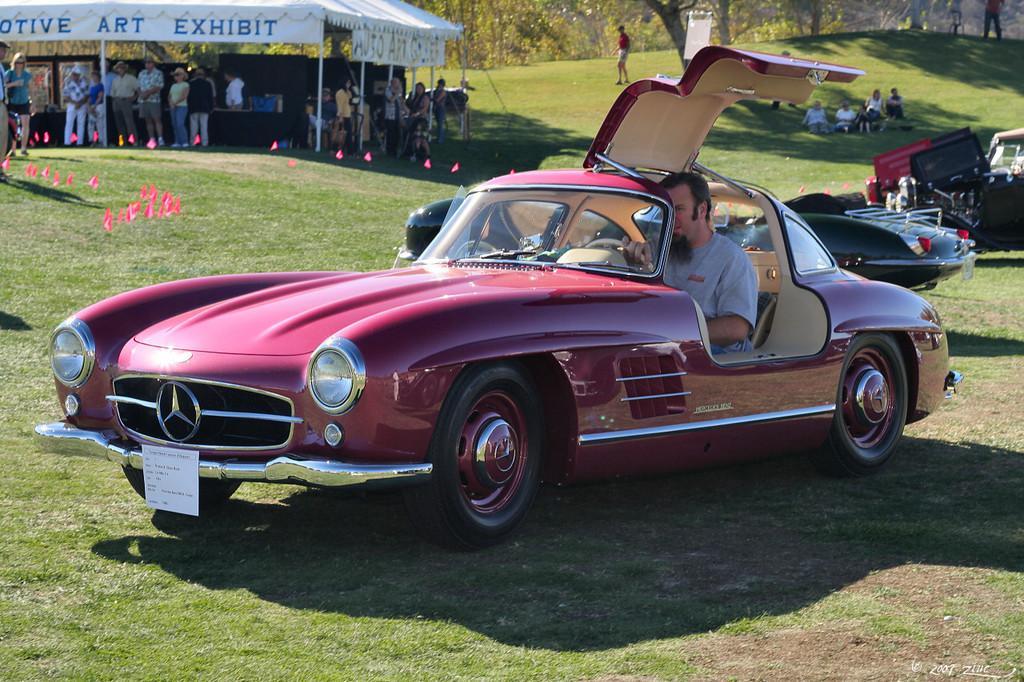Describe this image in one or two sentences. There is one person driving a car as we can see in the middle of this image. There are two other cars and some persons are sitting on a grassy land is on the left side of this image, and there are some persons standing on the left side of this image, and there are some trees in the background. 